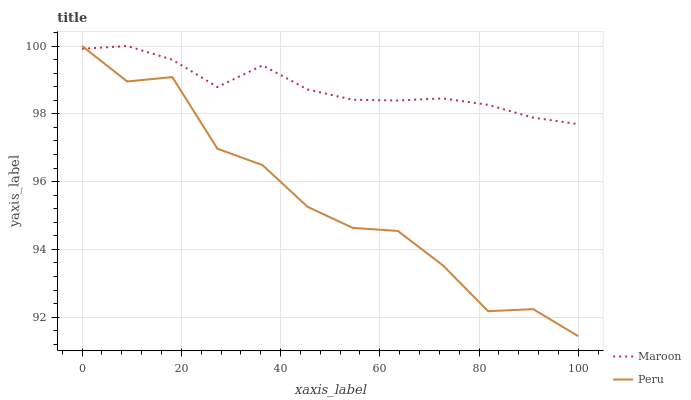Does Peru have the minimum area under the curve?
Answer yes or no. Yes. Does Maroon have the maximum area under the curve?
Answer yes or no. Yes. Does Maroon have the minimum area under the curve?
Answer yes or no. No. Is Maroon the smoothest?
Answer yes or no. Yes. Is Peru the roughest?
Answer yes or no. Yes. Is Maroon the roughest?
Answer yes or no. No. Does Peru have the lowest value?
Answer yes or no. Yes. Does Maroon have the lowest value?
Answer yes or no. No. Does Maroon have the highest value?
Answer yes or no. Yes. Does Maroon intersect Peru?
Answer yes or no. Yes. Is Maroon less than Peru?
Answer yes or no. No. Is Maroon greater than Peru?
Answer yes or no. No. 